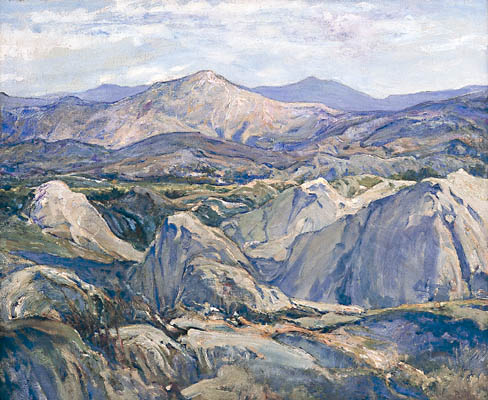How does this painting compare to actual mountainous regions you know of? This painting evokes the grandeur and tranquility of real mountainous regions, such as the Alps or the Rocky Mountains. The impressionistic style captures the essence of these landscapes, focusing more on the emotional and atmospheric qualities rather than precise detail. In places like the Alps, the mountains stand majestically, similar to the peaks in the painting, with lush valleys and rolling hills providing a serene contrast. The palette and brushstrokes might remind one of the serene yet imposing nature of these real-world mountains, making this painting a reflection of the artist’s interpretation of such awe-inspiring places. 